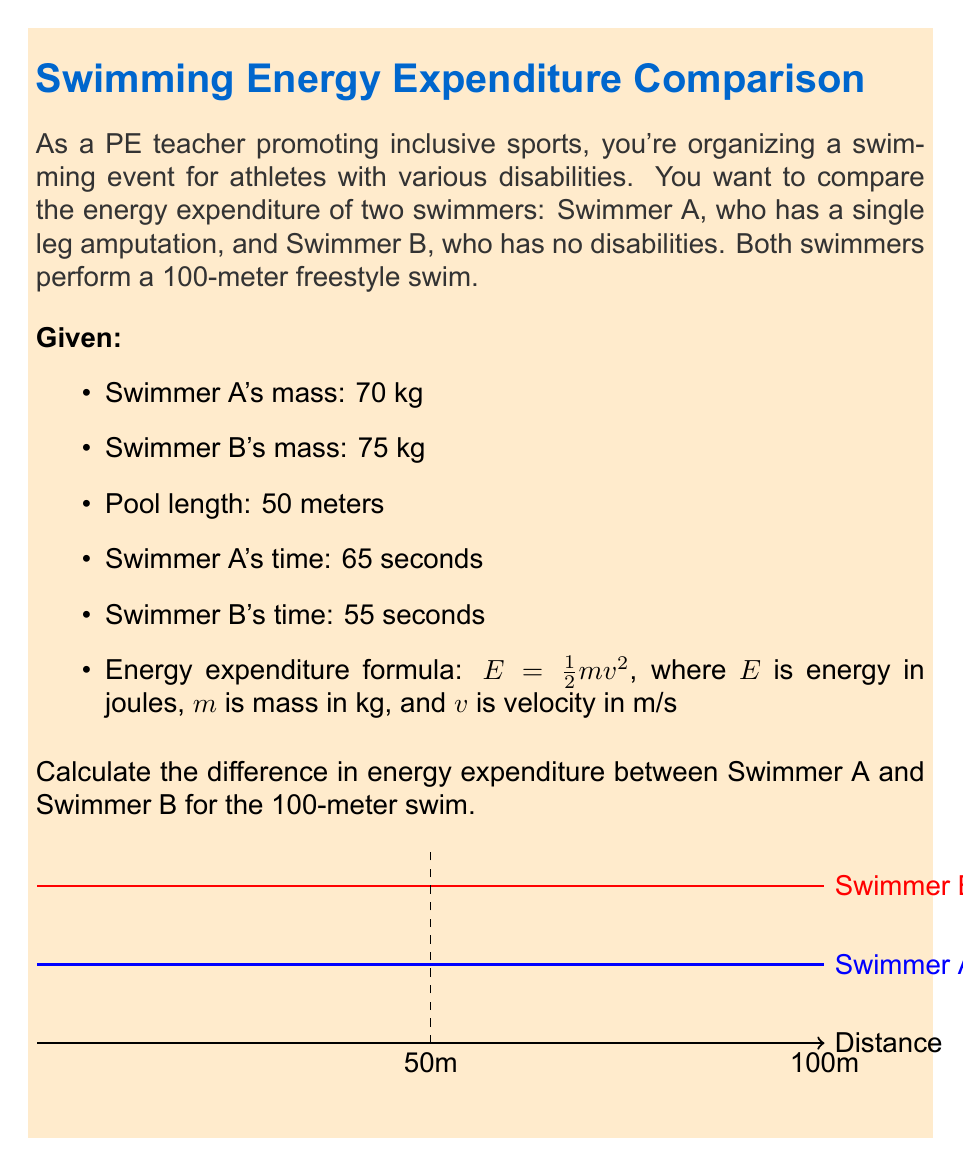Can you answer this question? Let's approach this step-by-step:

1) First, calculate the velocity for each swimmer:
   - Swimmer A: $v_A = \frac{100\text{ m}}{65\text{ s}} = 1.54\text{ m/s}$
   - Swimmer B: $v_B = \frac{100\text{ m}}{55\text{ s}} = 1.82\text{ m/s}$

2) Now, let's calculate the energy expenditure for each swimmer using $E = \frac{1}{2}mv^2$:

   For Swimmer A:
   $$E_A = \frac{1}{2} \cdot 70\text{ kg} \cdot (1.54\text{ m/s})^2 = 83.06\text{ J}$$

   For Swimmer B:
   $$E_B = \frac{1}{2} \cdot 75\text{ kg} \cdot (1.82\text{ m/s})^2 = 124.11\text{ J}$$

3) To find the difference in energy expenditure, subtract Swimmer A's energy from Swimmer B's:

   $$\Delta E = E_B - E_A = 124.11\text{ J} - 83.06\text{ J} = 41.05\text{ J}$$

Therefore, the difference in energy expenditure between Swimmer B and Swimmer A is 41.05 J.
Answer: 41.05 J 